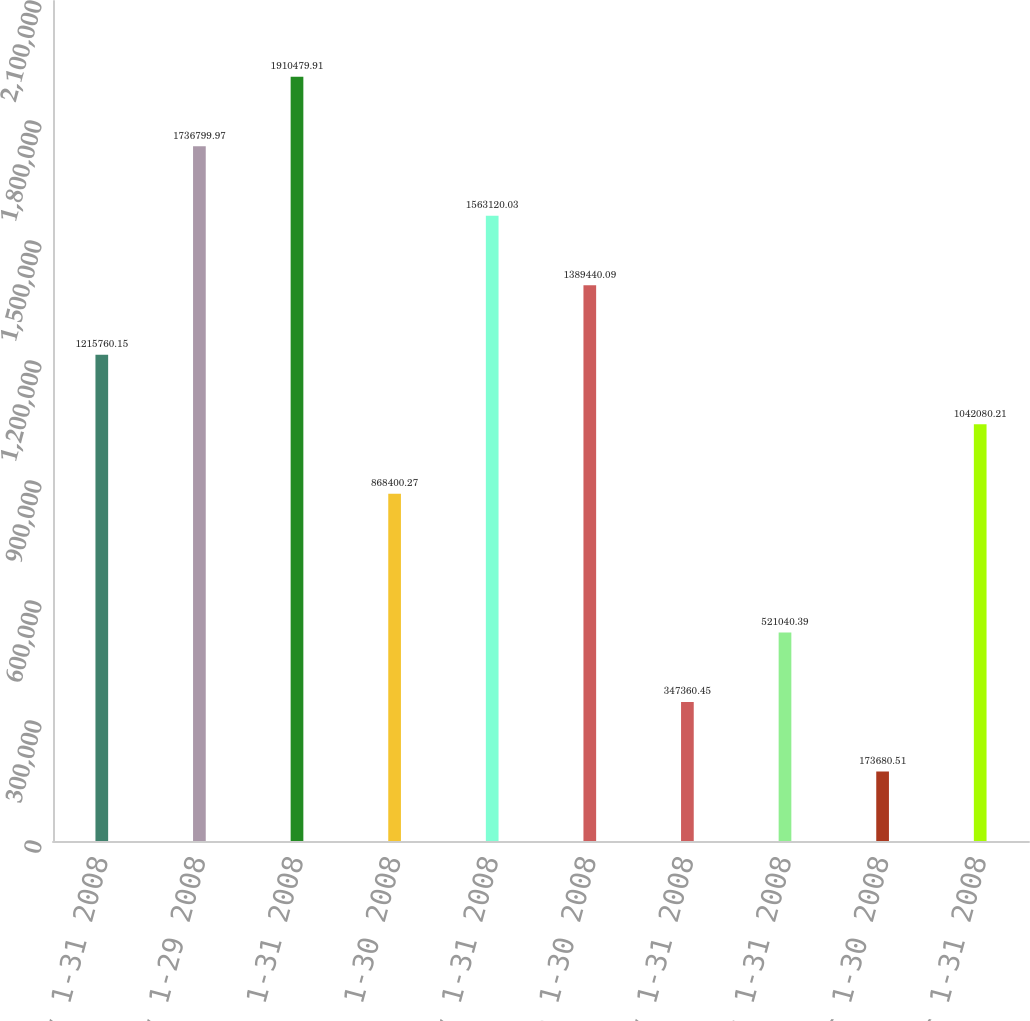Convert chart. <chart><loc_0><loc_0><loc_500><loc_500><bar_chart><fcel>January 1-31 2008<fcel>February 1-29 2008<fcel>March 1-31 2008<fcel>April 1-30 2008<fcel>May 1-31 2008<fcel>June 1-30 2008<fcel>July 1-31 2008<fcel>August 1-31 2008<fcel>September 1-30 2008<fcel>October 1-31 2008<nl><fcel>1.21576e+06<fcel>1.7368e+06<fcel>1.91048e+06<fcel>868400<fcel>1.56312e+06<fcel>1.38944e+06<fcel>347360<fcel>521040<fcel>173681<fcel>1.04208e+06<nl></chart> 